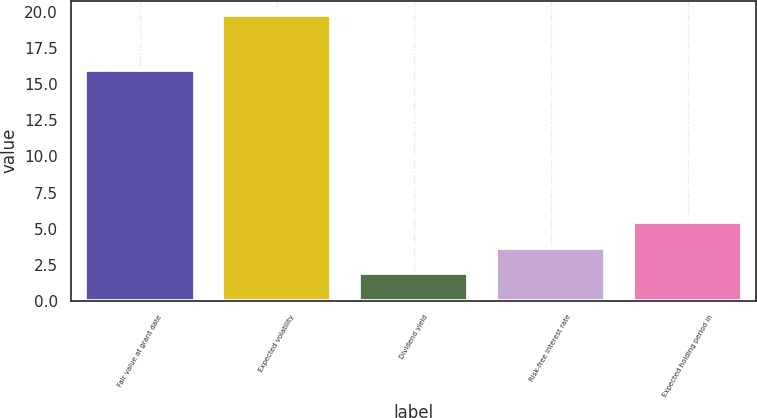Convert chart. <chart><loc_0><loc_0><loc_500><loc_500><bar_chart><fcel>Fair value at grant date<fcel>Expected volatility<fcel>Dividend yield<fcel>Risk-free interest rate<fcel>Expected holding period in<nl><fcel>15.98<fcel>19.8<fcel>1.9<fcel>3.69<fcel>5.48<nl></chart> 